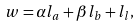<formula> <loc_0><loc_0><loc_500><loc_500>w = \alpha l _ { a } + \beta l _ { b } + l _ { l } ,</formula> 